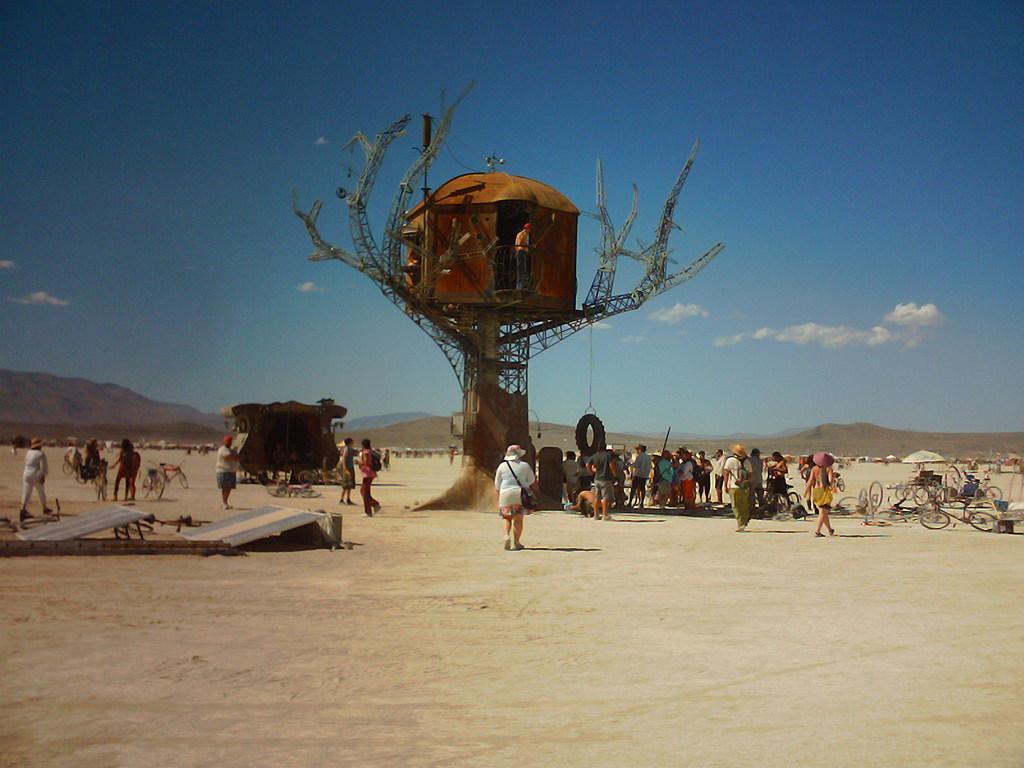Describe this image in one or two sentences. In this image I can see group of people, some are standing and some are walking and I can also see few bicycles. In the background I can see the tree house, the mountains and the sky is in blue and white color. 